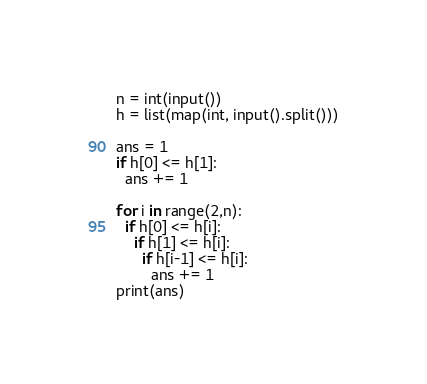Convert code to text. <code><loc_0><loc_0><loc_500><loc_500><_Python_>n = int(input())
h = list(map(int, input().split()))
 
ans = 1
if h[0] <= h[1]:
  ans += 1
 
for i in range(2,n):
  if h[0] <= h[i]:
    if h[1] <= h[i]:
      if h[i-1] <= h[i]:
        ans += 1
print(ans)</code> 